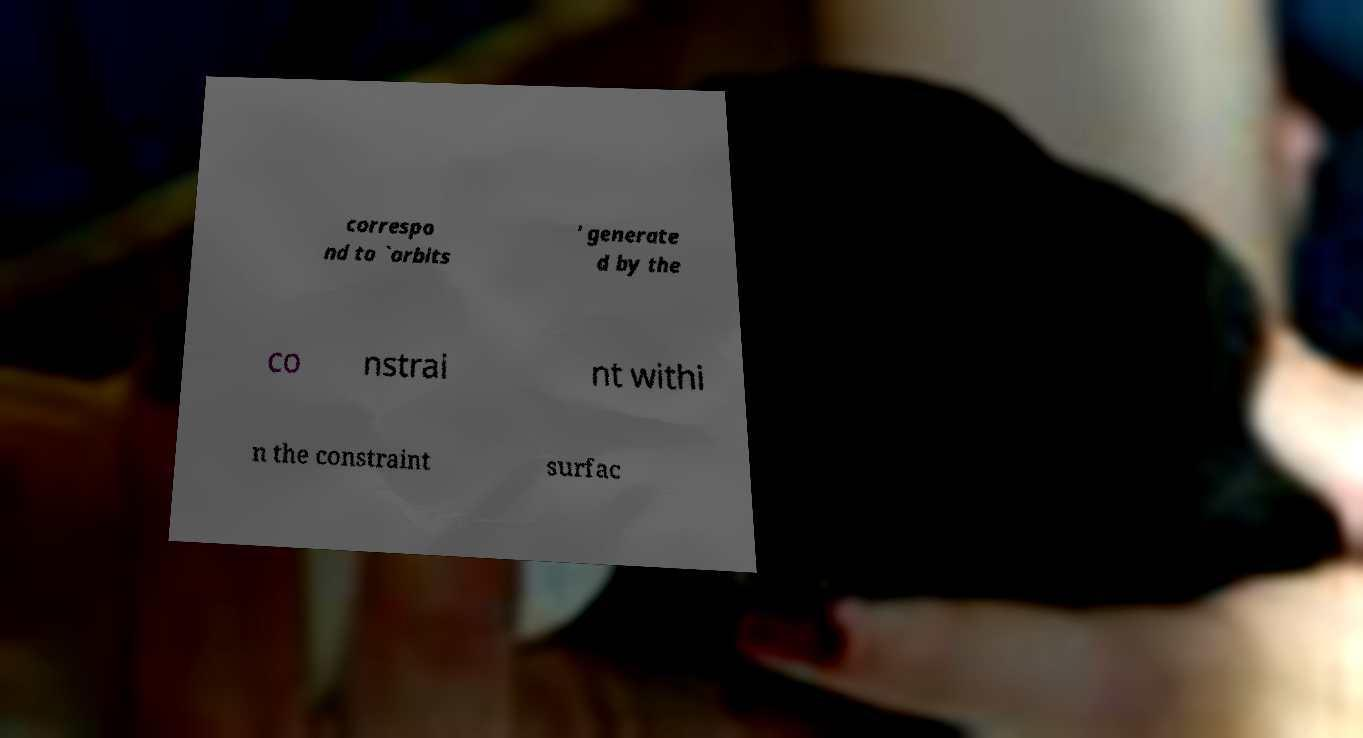Can you read and provide the text displayed in the image?This photo seems to have some interesting text. Can you extract and type it out for me? correspo nd to `orbits ' generate d by the co nstrai nt withi n the constraint surfac 